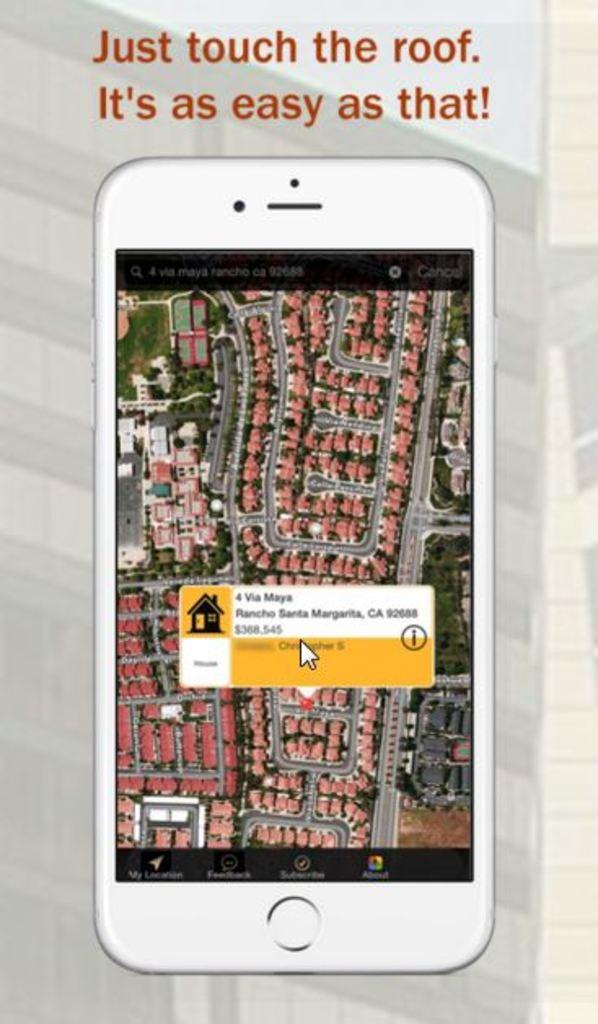Is this how to get an address from google maps?
Your answer should be very brief. Yes. What should you touch?
Make the answer very short. The roof. 